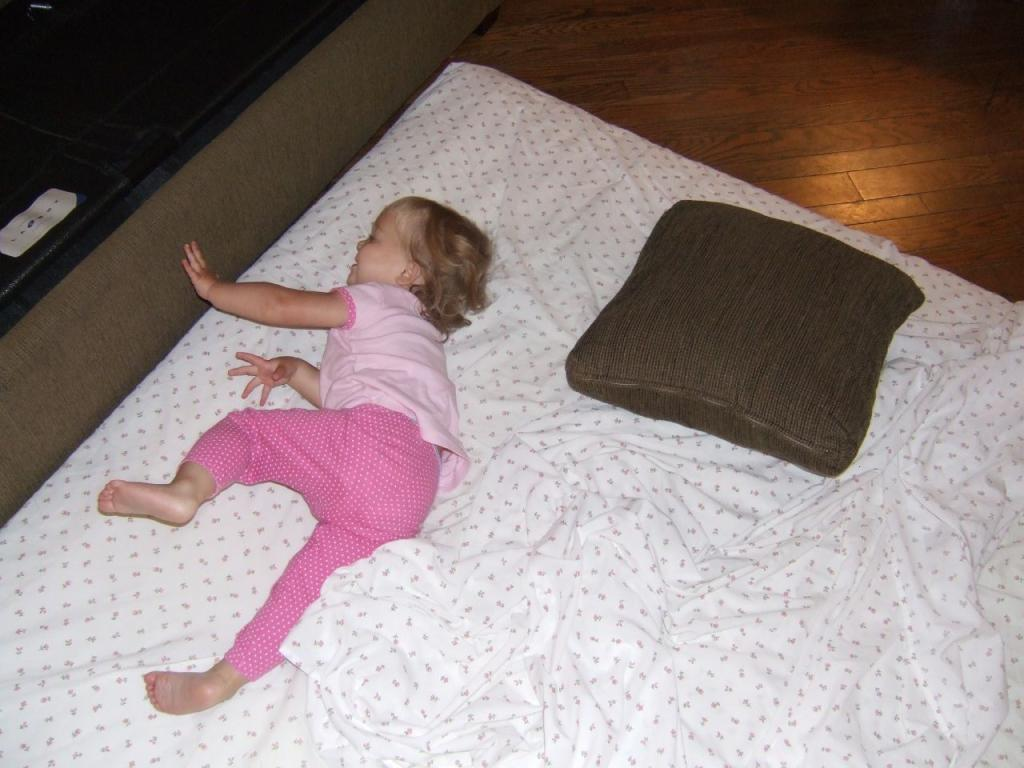What is the main subject of the image? There is a baby in the image. What is the baby doing in the image? The baby is sleeping on the bed. What is the baby wearing in the image? The baby is wearing a pink dress. What can be seen on the bed besides the baby? There is a pillow on the bed. What color is the bed sheet in the image? The bed sheet is white in color. What type of nation is represented by the baby in the image? The image does not represent any nation; it simply shows a baby sleeping on a bed. What kind of music is the band playing in the background of the image? There is no band or music present in the image; it only features a baby sleeping on a bed. 